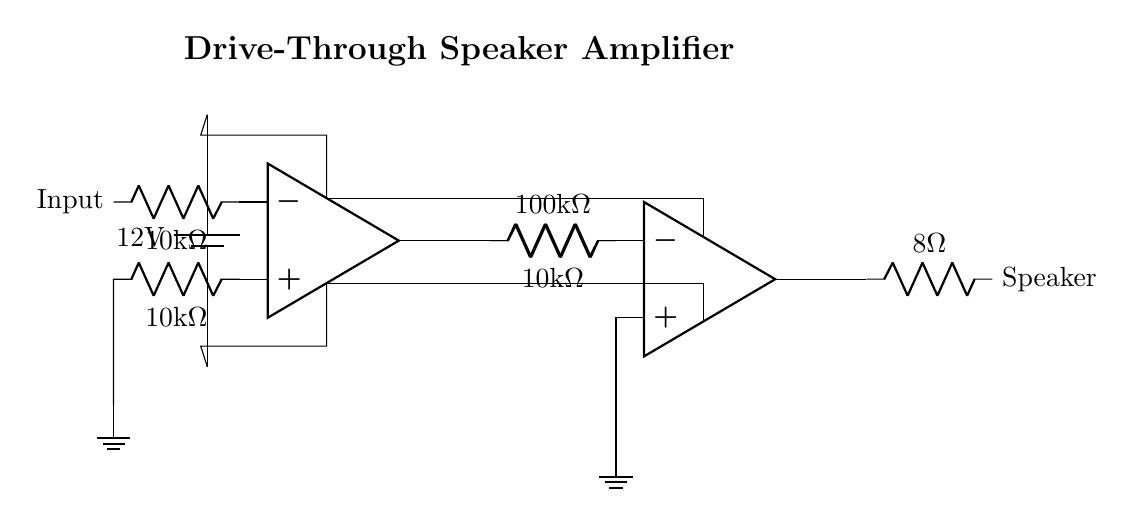What is the supply voltage in this circuit? The supply voltage is indicated by the battery symbol in the circuit diagram, which shows a value of 12V.
Answer: 12V What is the resistance value of the load connected to the output? The load connected to the output is represented by a resistor labeled with a value of 8 ohms.
Answer: 8 ohms How many operational amplifiers are used in this amplifier circuit? There are two operational amplifiers present in the circuit, indicated by the two op-amp symbols drawn in the diagram.
Answer: 2 What is the total resistance in the feedback path from the output of the second op-amp? The feedback path from the output of the second op-amp includes a resistor of 10k ohms connected to its inverting input, thus the total resistance in the feedback path is 10k ohms.
Answer: 10k ohms Explain why the input stage has a resistor connected to ground. The resistor connected to ground in the input stage serves as a biasing resistor, which establishes a reference point for the input signal. This helps to set the input level and improve circuit stability.
Answer: Biasing resistor 